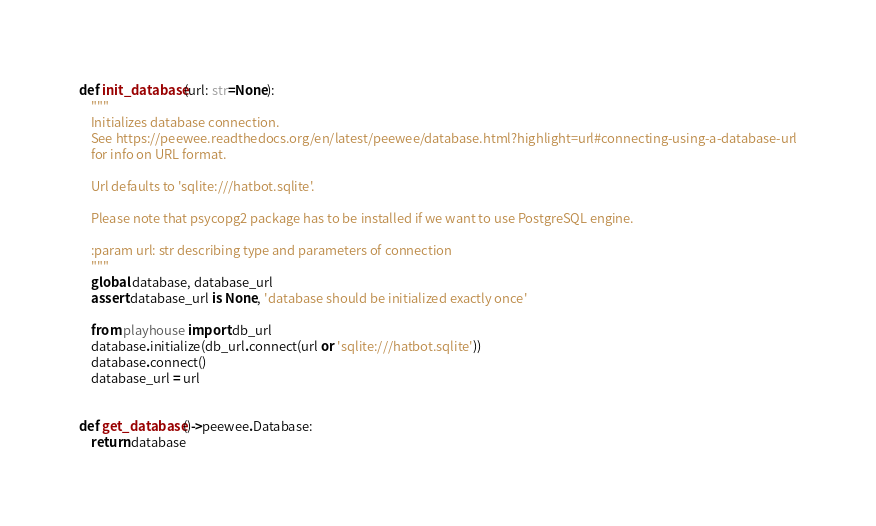<code> <loc_0><loc_0><loc_500><loc_500><_Python_>def init_database(url: str=None):
    """
    Initializes database connection.
    See https://peewee.readthedocs.org/en/latest/peewee/database.html?highlight=url#connecting-using-a-database-url
    for info on URL format.

    Url defaults to 'sqlite:///hatbot.sqlite'.

    Please note that psycopg2 package has to be installed if we want to use PostgreSQL engine.

    :param url: str describing type and parameters of connection
    """
    global database, database_url
    assert database_url is None, 'database should be initialized exactly once'

    from playhouse import db_url
    database.initialize(db_url.connect(url or 'sqlite:///hatbot.sqlite'))
    database.connect()
    database_url = url


def get_database()->peewee.Database:
    return database
</code> 